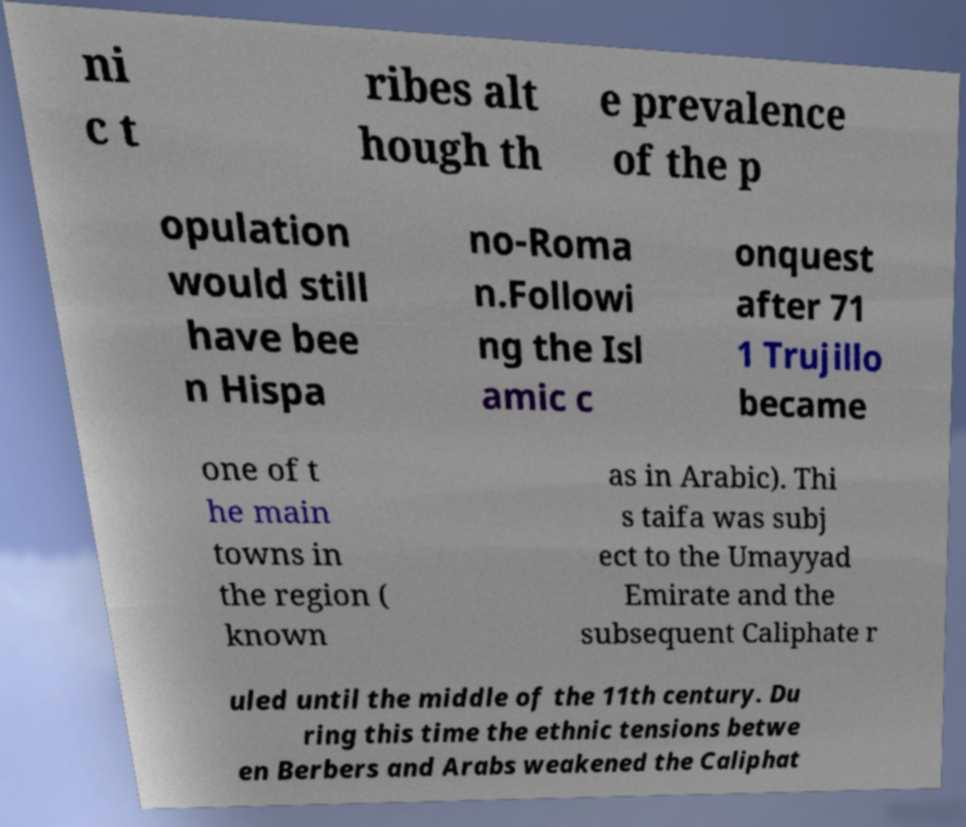Please identify and transcribe the text found in this image. ni c t ribes alt hough th e prevalence of the p opulation would still have bee n Hispa no-Roma n.Followi ng the Isl amic c onquest after 71 1 Trujillo became one of t he main towns in the region ( known as in Arabic). Thi s taifa was subj ect to the Umayyad Emirate and the subsequent Caliphate r uled until the middle of the 11th century. Du ring this time the ethnic tensions betwe en Berbers and Arabs weakened the Caliphat 